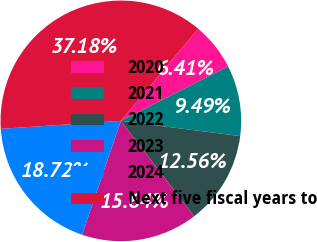Convert chart to OTSL. <chart><loc_0><loc_0><loc_500><loc_500><pie_chart><fcel>2020<fcel>2021<fcel>2022<fcel>2023<fcel>2024<fcel>Next five fiscal years to<nl><fcel>6.41%<fcel>9.49%<fcel>12.56%<fcel>15.64%<fcel>18.72%<fcel>37.18%<nl></chart> 